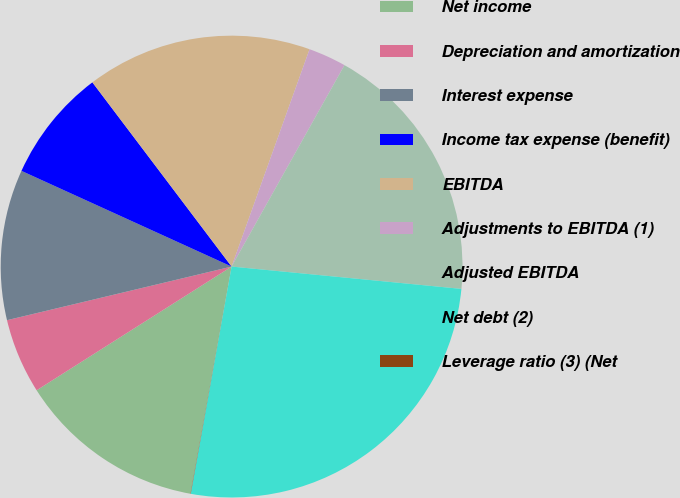Convert chart. <chart><loc_0><loc_0><loc_500><loc_500><pie_chart><fcel>Net income<fcel>Depreciation and amortization<fcel>Interest expense<fcel>Income tax expense (benefit)<fcel>EBITDA<fcel>Adjustments to EBITDA (1)<fcel>Adjusted EBITDA<fcel>Net debt (2)<fcel>Leverage ratio (3) (Net<nl><fcel>13.15%<fcel>5.27%<fcel>10.53%<fcel>7.9%<fcel>15.78%<fcel>2.65%<fcel>18.41%<fcel>26.29%<fcel>0.02%<nl></chart> 